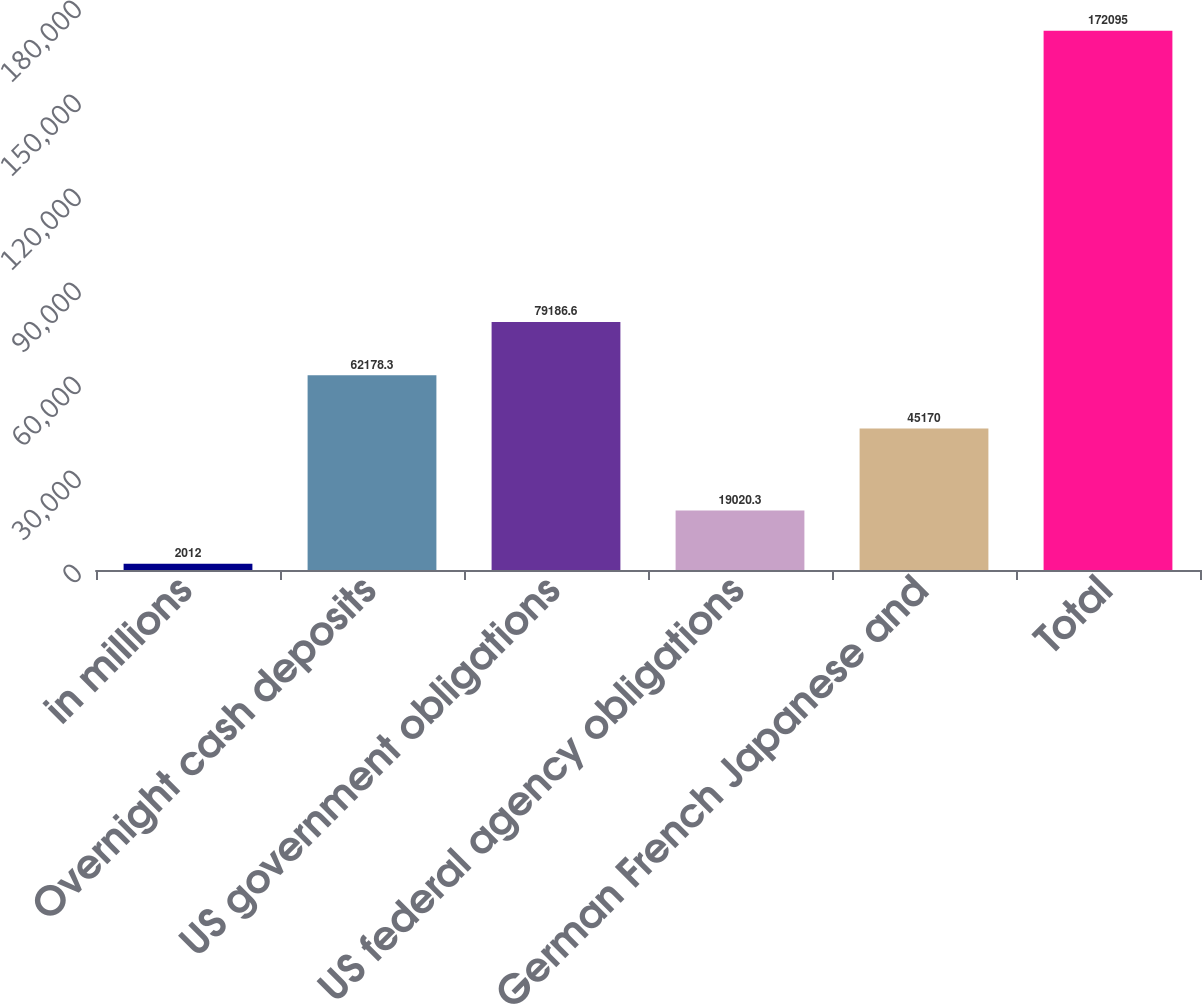Convert chart. <chart><loc_0><loc_0><loc_500><loc_500><bar_chart><fcel>in millions<fcel>Overnight cash deposits<fcel>US government obligations<fcel>US federal agency obligations<fcel>German French Japanese and<fcel>Total<nl><fcel>2012<fcel>62178.3<fcel>79186.6<fcel>19020.3<fcel>45170<fcel>172095<nl></chart> 